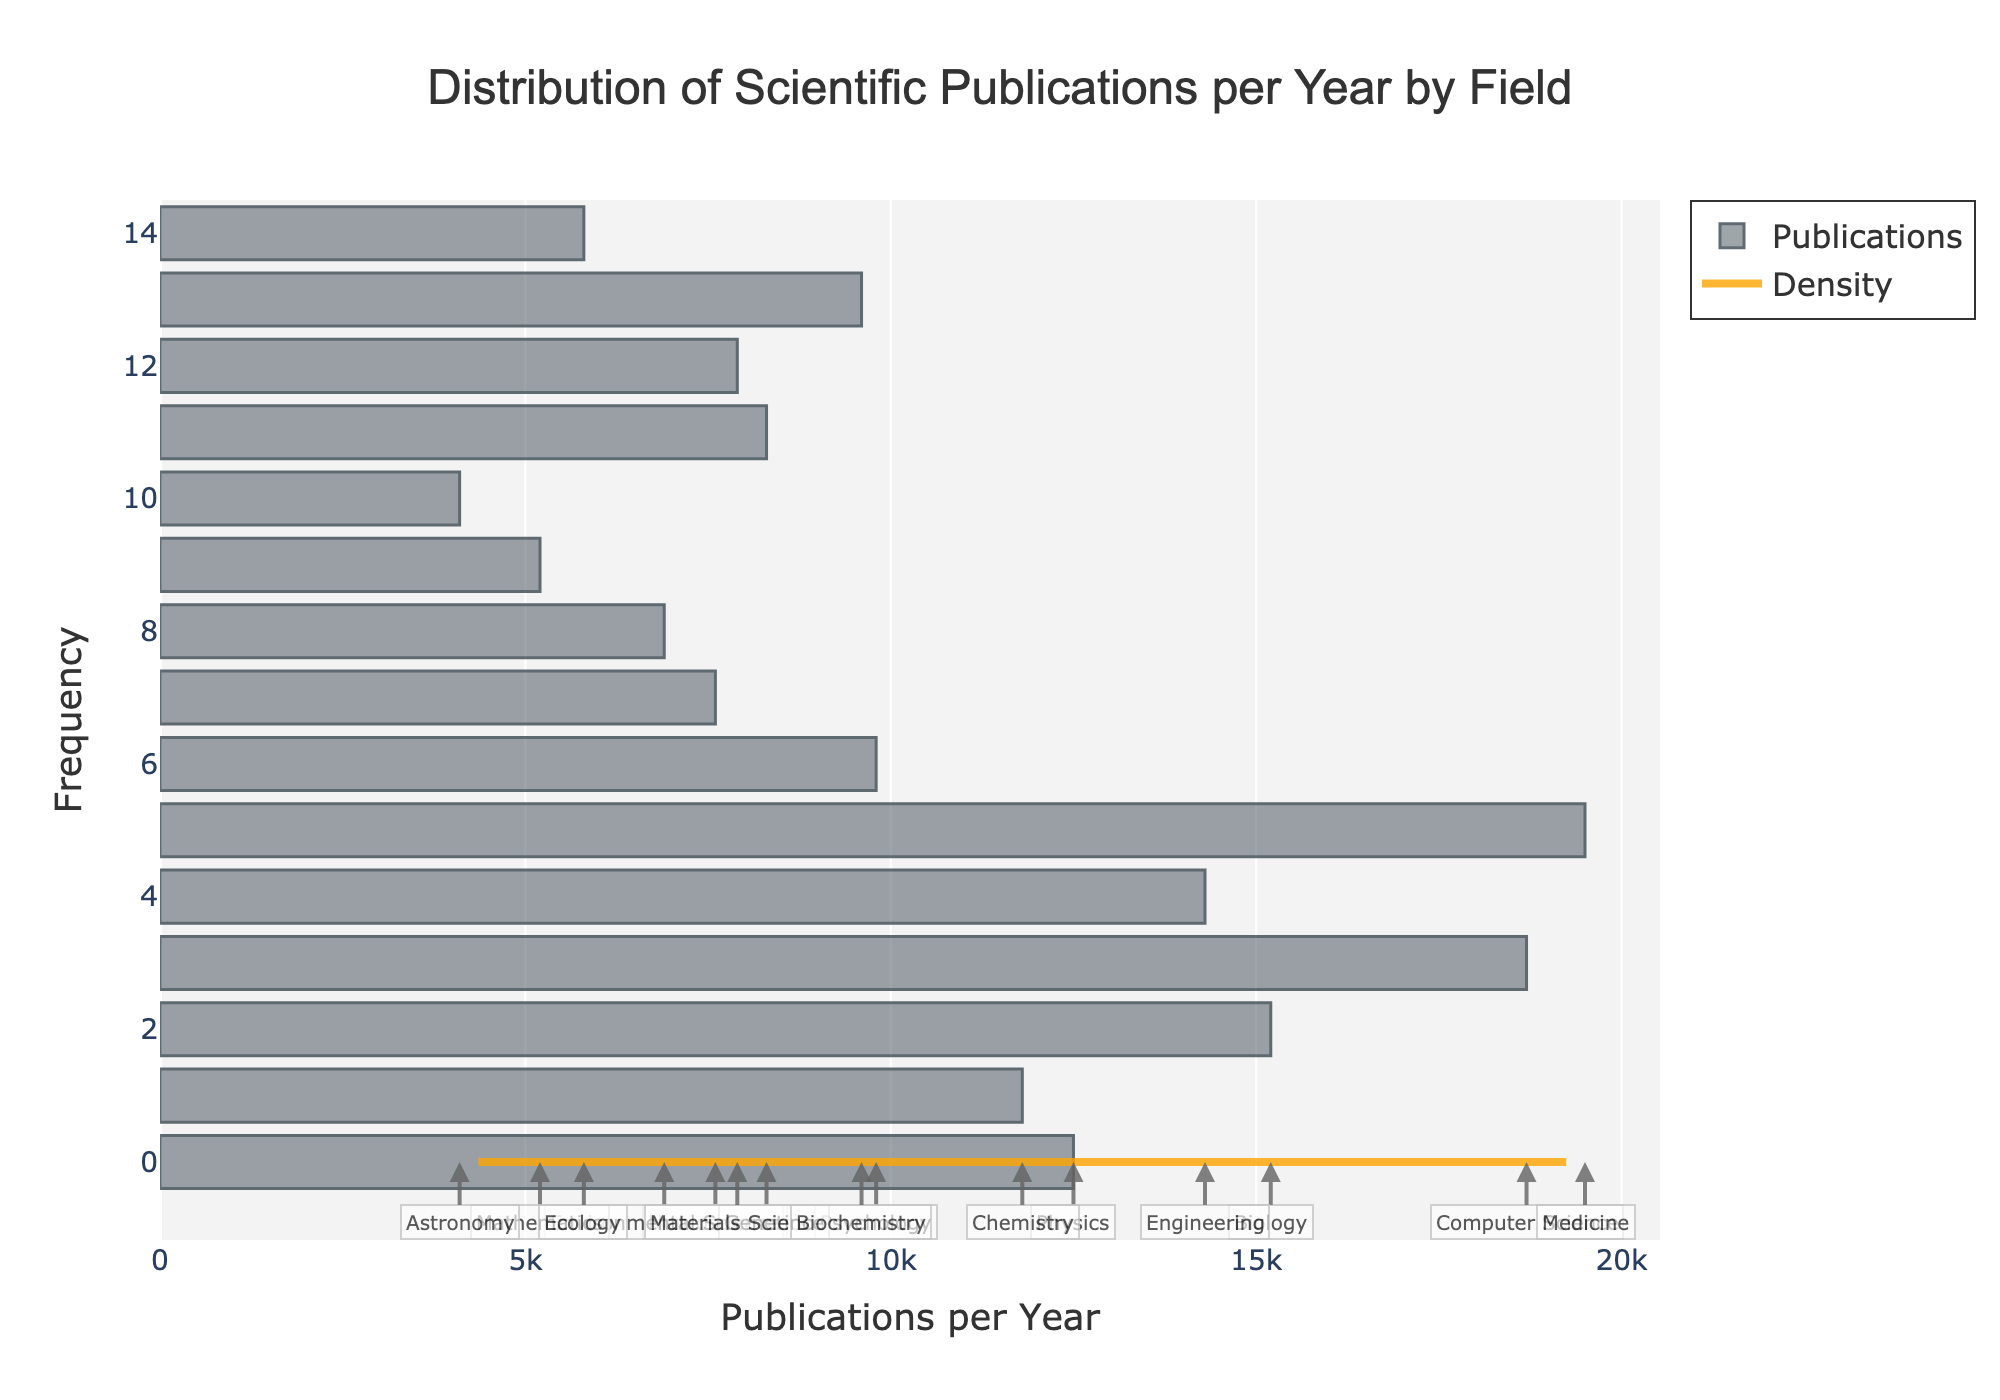what is the title of the figure? The title is displayed prominently at the top of the figure and reads, "Distribution of Scientific Publications per Year by Field".
Answer: Distribution of Scientific Publications per Year by Field what does the x-axis represent? The x-axis is labeled "Publications per Year" which indicates that it represents the number of scientific publications produced annually by each field.
Answer: Publications per Year which field has the highest number of publications per year? Medicine is positioned the furthest to the right on the x-axis, indicating it has the highest number of publications, which is 19500.
Answer: Medicine how many fields have publication rates between 10,000 and 20,000 publications per year? The sectors lying between the 10,000 and 20,000 marks on the x-axis are Chemistry, Physics, Biology, Engineering, Computer Science, and Medicine, totaling to 6 fields.
Answer: 6 fields what is the general pattern shown by the KDE curve? The KDE (density) curve shows that most fields have a moderate number of publications with the density peaking between 10,000 and 20,000 publications per year, then tapering off as the publication count increases or decreases.
Answer: Peak between 10,000 and 20,000 compare the publication rates of Neuroscience and Environmental Science Neuroscience has a higher publication rate of 7,600 compared to Environmental Science, which has 6,900, indicative by where they fall on the x-axis.
Answer: Neuroscience > Environmental Science which fields have fewer publications than Psychology? Fields to the left of Psychology on the x-axis with 9800 publications per year are Neuroscience, Environmental Science, Astronomy, Mathematics, Ecology, and Genetics.
Answer: Neuroscience, Environmental Science, Astronomy, Mathematics, Ecology, Genetics what is the trend of the density curve around the 15,000 publications mark? The density curve rises again around the 15,000 publications mark, as indicated by the notable increase where Biology resides.
Answer: It rises how does the frequency of publications in Computer Science compare to Biochemistry? Both fields are close in publication frequency as seen from their proximity on the x-axis, with Computer Science slightly higher at 18,700 publications per year compared to Biochemistry’s 9,600.
Answer: Computer Science > Biochemistry 